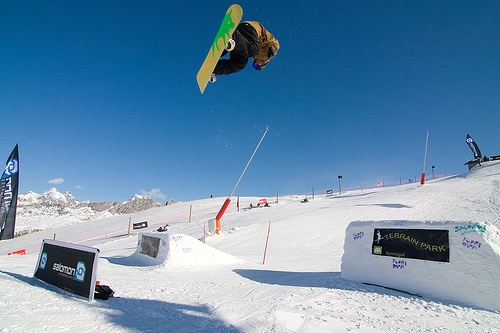Describe the objects in this image and their specific colors. I can see people in blue, black, maroon, olive, and tan tones and snowboard in blue, olive, and green tones in this image. 